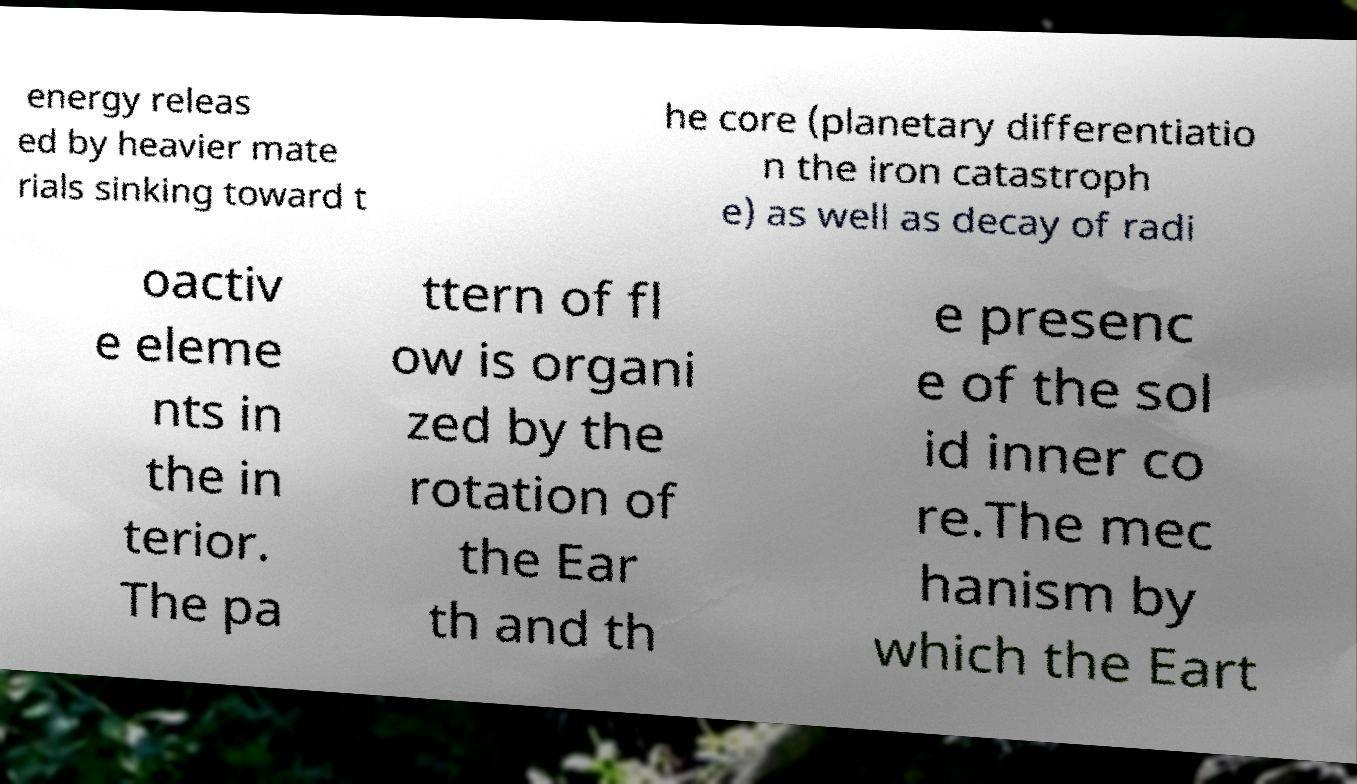There's text embedded in this image that I need extracted. Can you transcribe it verbatim? energy releas ed by heavier mate rials sinking toward t he core (planetary differentiatio n the iron catastroph e) as well as decay of radi oactiv e eleme nts in the in terior. The pa ttern of fl ow is organi zed by the rotation of the Ear th and th e presenc e of the sol id inner co re.The mec hanism by which the Eart 